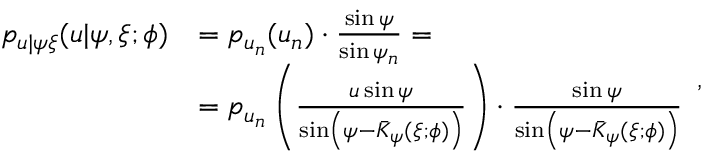<formula> <loc_0><loc_0><loc_500><loc_500>\begin{array} { r l } { p _ { u | \psi \xi } ( u | \psi , \xi ; \phi ) } & { = p _ { u _ { n } } ( u _ { n } ) \cdot \frac { \sin \psi } { \sin \psi _ { n } } = } \\ & { = p _ { u _ { n } } \left ( \frac { u \sin \psi } { \sin \left ( \psi - \bar { K } _ { \psi } ( \xi ; \phi ) \right ) } \right ) \cdot \frac { \sin \psi } { \sin \left ( \psi - \bar { K } _ { \psi } ( \xi ; \phi ) \right ) } } \end{array} ,</formula> 